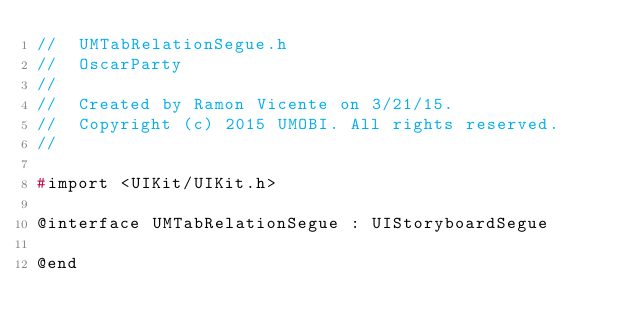<code> <loc_0><loc_0><loc_500><loc_500><_C_>//  UMTabRelationSegue.h
//  OscarParty
//
//  Created by Ramon Vicente on 3/21/15.
//  Copyright (c) 2015 UMOBI. All rights reserved.
//

#import <UIKit/UIKit.h>

@interface UMTabRelationSegue : UIStoryboardSegue

@end
</code> 